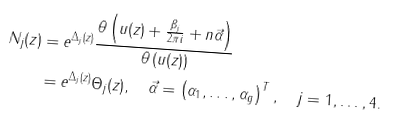Convert formula to latex. <formula><loc_0><loc_0><loc_500><loc_500>N _ { j } ( z ) & = e ^ { \Delta _ { j } ( z ) } \frac { \theta \left ( u ( z ) + \frac { \beta _ { j } } { 2 \pi i } + n \vec { \alpha } \right ) } { \theta \left ( u ( z ) \right ) } \\ & = e ^ { \Delta _ { j } ( z ) } \Theta _ { j } ( z ) , \quad \vec { \alpha } = \left ( \alpha _ { 1 } , \dots , \alpha _ { g } \right ) ^ { T } , \quad j = 1 , \dots , 4 .</formula> 